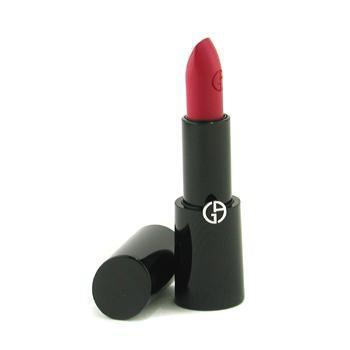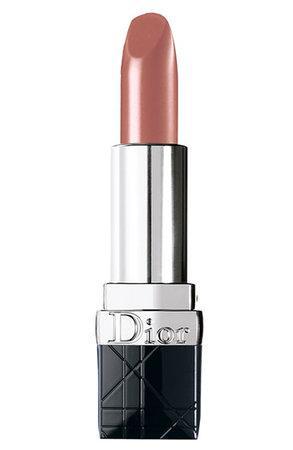The first image is the image on the left, the second image is the image on the right. Given the left and right images, does the statement "One open tube of lipstick is black with a visible logo somewhere on the tube, and the black cap laying sideways beside it." hold true? Answer yes or no. Yes. The first image is the image on the left, the second image is the image on the right. Evaluate the accuracy of this statement regarding the images: "An image shows an upright solid black tube of red lipstick with its black cylindrical cap alongside it.". Is it true? Answer yes or no. Yes. 